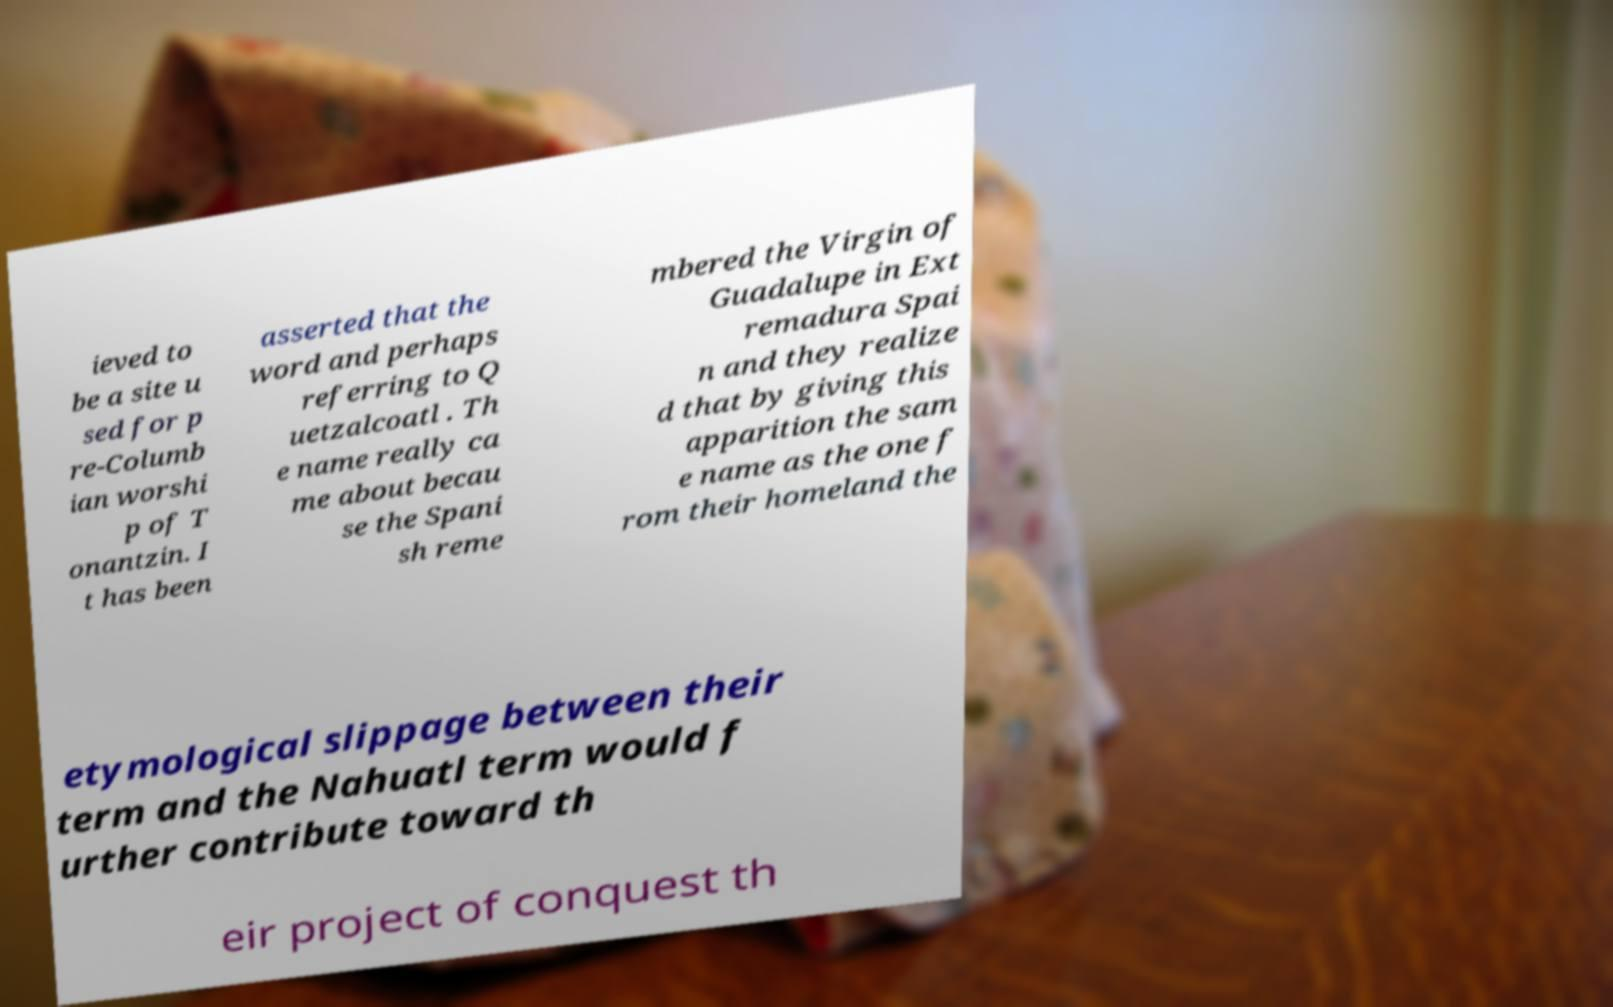Could you assist in decoding the text presented in this image and type it out clearly? ieved to be a site u sed for p re-Columb ian worshi p of T onantzin. I t has been asserted that the word and perhaps referring to Q uetzalcoatl . Th e name really ca me about becau se the Spani sh reme mbered the Virgin of Guadalupe in Ext remadura Spai n and they realize d that by giving this apparition the sam e name as the one f rom their homeland the etymological slippage between their term and the Nahuatl term would f urther contribute toward th eir project of conquest th 